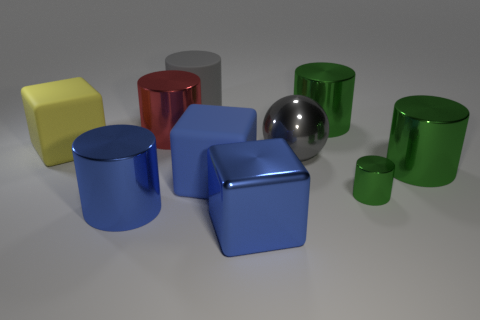Subtract all big cylinders. How many cylinders are left? 1 Subtract all green cylinders. How many blue blocks are left? 2 Subtract 1 blocks. How many blocks are left? 2 Subtract all yellow cubes. How many cubes are left? 2 Subtract all cylinders. How many objects are left? 4 Subtract all purple blocks. Subtract all blue spheres. How many blocks are left? 3 Add 4 big rubber cubes. How many big rubber cubes exist? 6 Subtract 0 brown balls. How many objects are left? 10 Subtract all large blue rubber blocks. Subtract all yellow cubes. How many objects are left? 8 Add 8 big metal cubes. How many big metal cubes are left? 9 